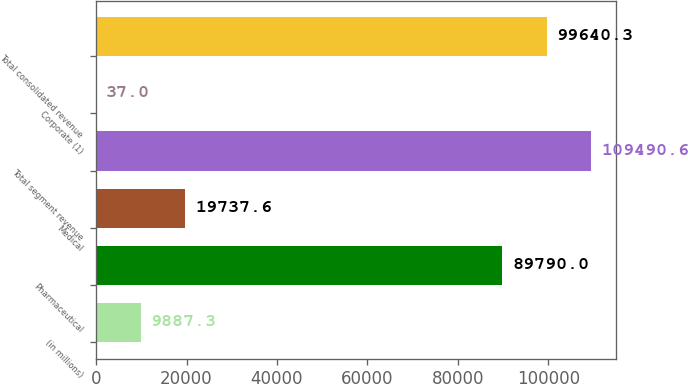Convert chart. <chart><loc_0><loc_0><loc_500><loc_500><bar_chart><fcel>(in millions)<fcel>Pharmaceutical<fcel>Medical<fcel>Total segment revenue<fcel>Corporate (1)<fcel>Total consolidated revenue<nl><fcel>9887.3<fcel>89790<fcel>19737.6<fcel>109491<fcel>37<fcel>99640.3<nl></chart> 